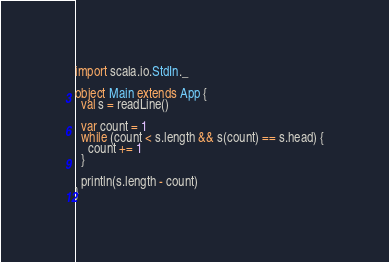<code> <loc_0><loc_0><loc_500><loc_500><_Scala_>import scala.io.StdIn._

object Main extends App {
  val s = readLine()

  var count = 1
  while (count < s.length && s(count) == s.head) {
    count += 1
  }

  println(s.length - count)
}
</code> 